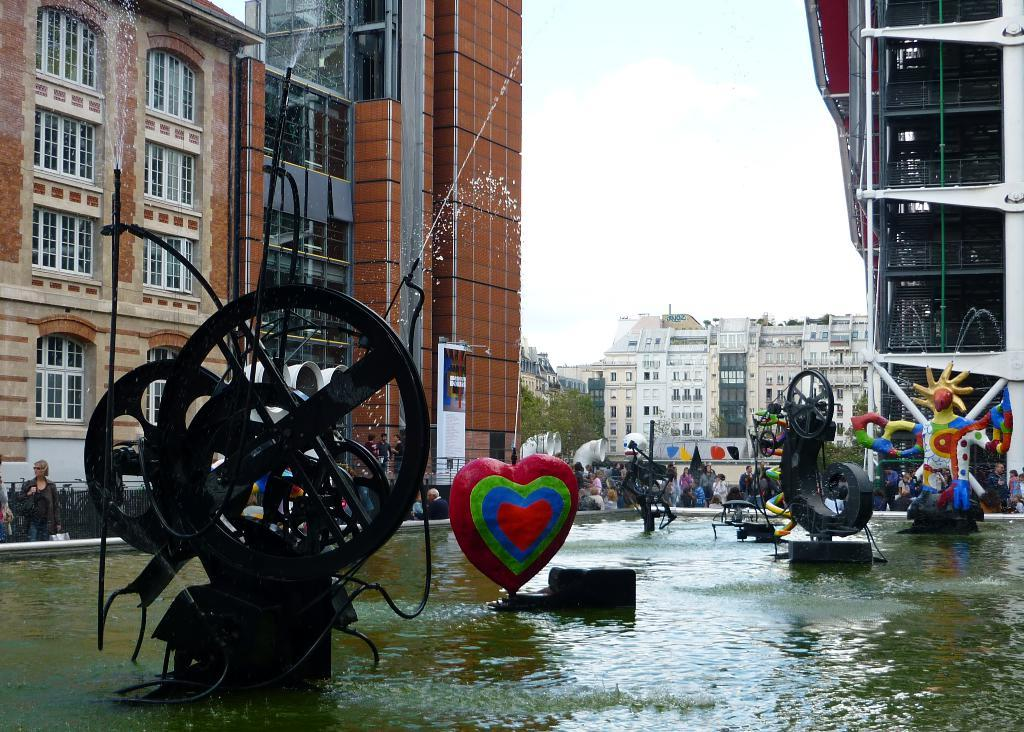What is on the surface of the water in the image? There are objects on the surface of the water in the image. What can be seen in the distance behind the water? There are buildings, trees, and people in the background of the image. What is visible at the top of the image? The sky is visible at the top of the image. What type of joke can be seen being told by the thing in the image? There is no joke or thing present in the image; it features objects on the surface of the water, buildings, trees, people, and the sky. 